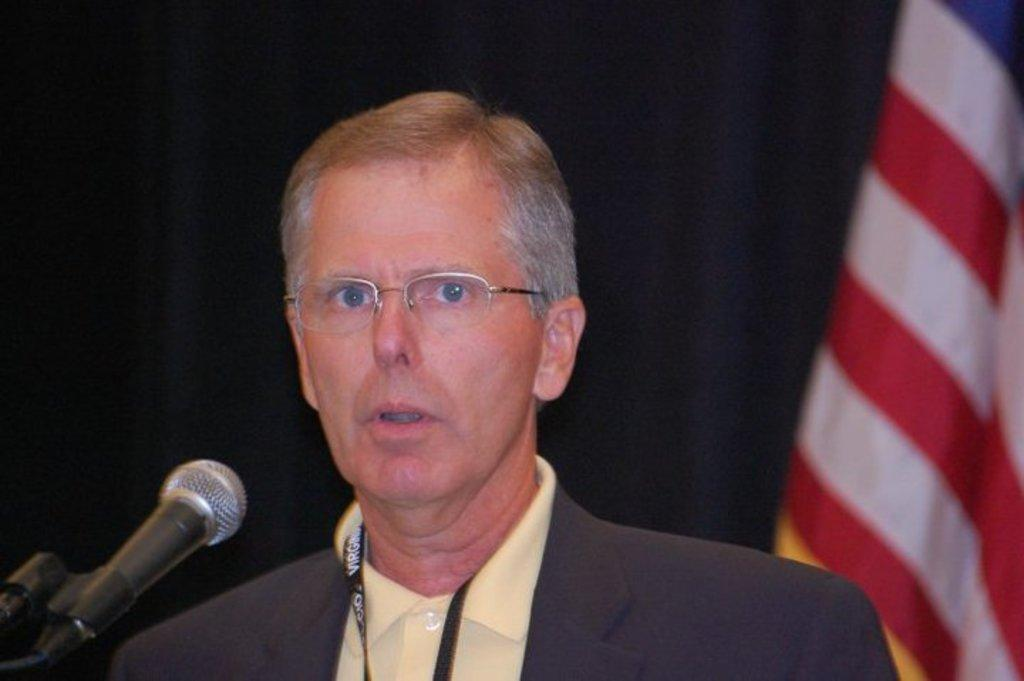Who is the main subject in the image? There is a man in the center of the image. What is the man wearing that provides identification? The man is wearing an ID card. What accessory is the man wearing on his face? The man is wearing glasses. What device is present in the image for amplifying sound? There is a microphone in the image. What type of background element can be seen in the image? There is a curtain and a flag in the background of the image. What type of celery is being used as a prop in the image? There is no celery present in the image. Can you tell me how many coasts are visible in the image? There are no coasts visible in the image. 